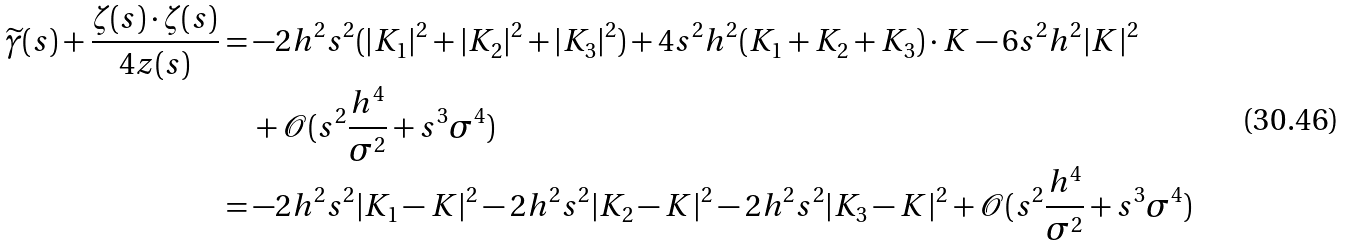Convert formula to latex. <formula><loc_0><loc_0><loc_500><loc_500>\widetilde { \gamma } ( s ) + \frac { \zeta ( s ) \cdot \zeta ( s ) } { 4 z ( s ) } & = - 2 h ^ { 2 } s ^ { 2 } ( | K _ { 1 } | ^ { 2 } + | K _ { 2 } | ^ { 2 } + | K _ { 3 } | ^ { 2 } ) + 4 s ^ { 2 } h ^ { 2 } ( K _ { 1 } + K _ { 2 } + K _ { 3 } ) \cdot K - 6 s ^ { 2 } h ^ { 2 } | K | ^ { 2 } \\ & \quad + \mathcal { O } ( s ^ { 2 } \frac { h ^ { 4 } } { \sigma ^ { 2 } } + s ^ { 3 } \sigma ^ { 4 } ) \\ & = - 2 h ^ { 2 } s ^ { 2 } | K _ { 1 } - K | ^ { 2 } - 2 h ^ { 2 } s ^ { 2 } | K _ { 2 } - K | ^ { 2 } - 2 h ^ { 2 } s ^ { 2 } | K _ { 3 } - K | ^ { 2 } + \mathcal { O } ( s ^ { 2 } \frac { h ^ { 4 } } { \sigma ^ { 2 } } + s ^ { 3 } \sigma ^ { 4 } )</formula> 